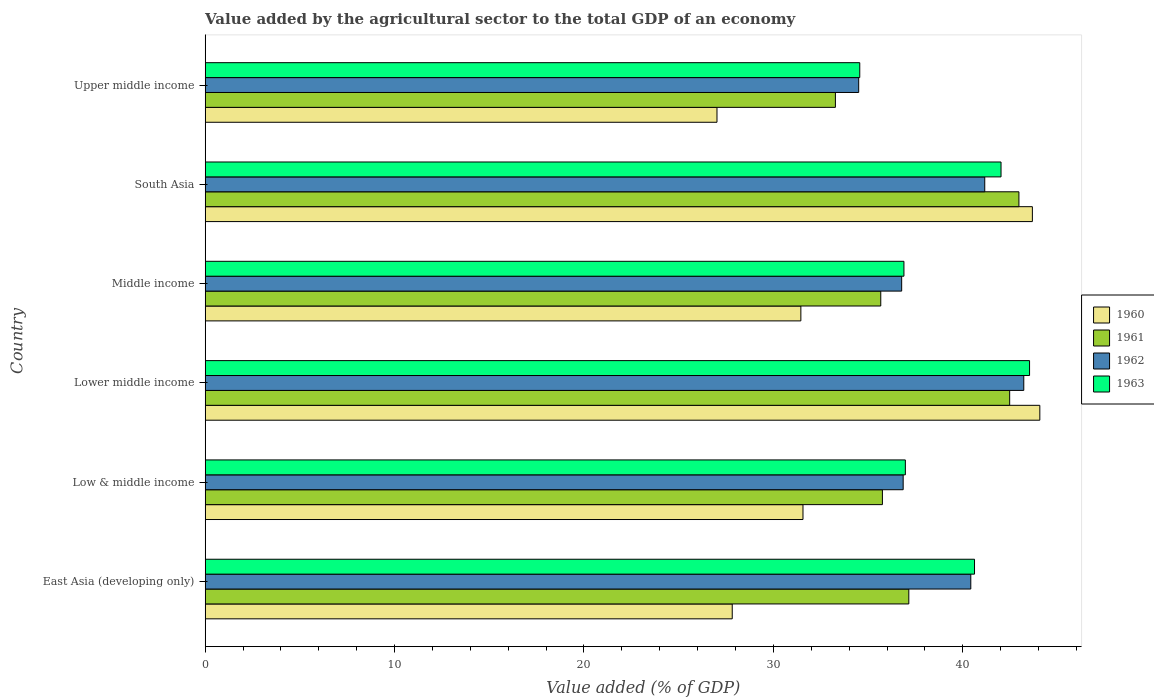Are the number of bars per tick equal to the number of legend labels?
Your answer should be very brief. Yes. How many bars are there on the 5th tick from the top?
Provide a succinct answer. 4. What is the label of the 4th group of bars from the top?
Keep it short and to the point. Lower middle income. In how many cases, is the number of bars for a given country not equal to the number of legend labels?
Make the answer very short. 0. What is the value added by the agricultural sector to the total GDP in 1963 in Upper middle income?
Offer a very short reply. 34.56. Across all countries, what is the maximum value added by the agricultural sector to the total GDP in 1962?
Your answer should be very brief. 43.22. Across all countries, what is the minimum value added by the agricultural sector to the total GDP in 1963?
Offer a very short reply. 34.56. In which country was the value added by the agricultural sector to the total GDP in 1960 maximum?
Your response must be concise. Lower middle income. In which country was the value added by the agricultural sector to the total GDP in 1961 minimum?
Your answer should be very brief. Upper middle income. What is the total value added by the agricultural sector to the total GDP in 1962 in the graph?
Make the answer very short. 232.94. What is the difference between the value added by the agricultural sector to the total GDP in 1963 in Low & middle income and that in South Asia?
Give a very brief answer. -5.05. What is the difference between the value added by the agricultural sector to the total GDP in 1961 in South Asia and the value added by the agricultural sector to the total GDP in 1963 in Upper middle income?
Provide a short and direct response. 8.4. What is the average value added by the agricultural sector to the total GDP in 1961 per country?
Give a very brief answer. 37.88. What is the difference between the value added by the agricultural sector to the total GDP in 1963 and value added by the agricultural sector to the total GDP in 1962 in Upper middle income?
Ensure brevity in your answer.  0.06. In how many countries, is the value added by the agricultural sector to the total GDP in 1962 greater than 18 %?
Give a very brief answer. 6. What is the ratio of the value added by the agricultural sector to the total GDP in 1960 in East Asia (developing only) to that in Middle income?
Provide a short and direct response. 0.88. Is the value added by the agricultural sector to the total GDP in 1961 in Low & middle income less than that in Lower middle income?
Give a very brief answer. Yes. What is the difference between the highest and the second highest value added by the agricultural sector to the total GDP in 1961?
Your response must be concise. 0.49. What is the difference between the highest and the lowest value added by the agricultural sector to the total GDP in 1961?
Your response must be concise. 9.69. In how many countries, is the value added by the agricultural sector to the total GDP in 1961 greater than the average value added by the agricultural sector to the total GDP in 1961 taken over all countries?
Your answer should be very brief. 2. Is the sum of the value added by the agricultural sector to the total GDP in 1961 in Lower middle income and Middle income greater than the maximum value added by the agricultural sector to the total GDP in 1960 across all countries?
Offer a very short reply. Yes. Is it the case that in every country, the sum of the value added by the agricultural sector to the total GDP in 1963 and value added by the agricultural sector to the total GDP in 1962 is greater than the sum of value added by the agricultural sector to the total GDP in 1960 and value added by the agricultural sector to the total GDP in 1961?
Provide a short and direct response. No. What does the 4th bar from the top in Lower middle income represents?
Your answer should be very brief. 1960. Are all the bars in the graph horizontal?
Your response must be concise. Yes. What is the difference between two consecutive major ticks on the X-axis?
Keep it short and to the point. 10. Are the values on the major ticks of X-axis written in scientific E-notation?
Provide a succinct answer. No. Does the graph contain any zero values?
Make the answer very short. No. How many legend labels are there?
Offer a terse response. 4. How are the legend labels stacked?
Give a very brief answer. Vertical. What is the title of the graph?
Your answer should be very brief. Value added by the agricultural sector to the total GDP of an economy. What is the label or title of the X-axis?
Provide a short and direct response. Value added (% of GDP). What is the label or title of the Y-axis?
Ensure brevity in your answer.  Country. What is the Value added (% of GDP) in 1960 in East Asia (developing only)?
Keep it short and to the point. 27.83. What is the Value added (% of GDP) in 1961 in East Asia (developing only)?
Provide a short and direct response. 37.15. What is the Value added (% of GDP) in 1962 in East Asia (developing only)?
Offer a very short reply. 40.42. What is the Value added (% of GDP) of 1963 in East Asia (developing only)?
Provide a succinct answer. 40.62. What is the Value added (% of GDP) of 1960 in Low & middle income?
Offer a very short reply. 31.56. What is the Value added (% of GDP) in 1961 in Low & middle income?
Offer a terse response. 35.76. What is the Value added (% of GDP) in 1962 in Low & middle income?
Your response must be concise. 36.85. What is the Value added (% of GDP) in 1963 in Low & middle income?
Provide a succinct answer. 36.97. What is the Value added (% of GDP) in 1960 in Lower middle income?
Offer a terse response. 44.07. What is the Value added (% of GDP) of 1961 in Lower middle income?
Give a very brief answer. 42.48. What is the Value added (% of GDP) of 1962 in Lower middle income?
Your answer should be compact. 43.22. What is the Value added (% of GDP) of 1963 in Lower middle income?
Make the answer very short. 43.53. What is the Value added (% of GDP) in 1960 in Middle income?
Provide a succinct answer. 31.45. What is the Value added (% of GDP) in 1961 in Middle income?
Give a very brief answer. 35.67. What is the Value added (% of GDP) of 1962 in Middle income?
Your response must be concise. 36.77. What is the Value added (% of GDP) in 1963 in Middle income?
Your answer should be compact. 36.89. What is the Value added (% of GDP) in 1960 in South Asia?
Offer a terse response. 43.68. What is the Value added (% of GDP) in 1961 in South Asia?
Your answer should be compact. 42.96. What is the Value added (% of GDP) of 1962 in South Asia?
Give a very brief answer. 41.16. What is the Value added (% of GDP) of 1963 in South Asia?
Make the answer very short. 42.02. What is the Value added (% of GDP) of 1960 in Upper middle income?
Your response must be concise. 27.02. What is the Value added (% of GDP) in 1961 in Upper middle income?
Your response must be concise. 33.27. What is the Value added (% of GDP) of 1962 in Upper middle income?
Ensure brevity in your answer.  34.5. What is the Value added (% of GDP) in 1963 in Upper middle income?
Offer a terse response. 34.56. Across all countries, what is the maximum Value added (% of GDP) of 1960?
Your answer should be very brief. 44.07. Across all countries, what is the maximum Value added (% of GDP) in 1961?
Your answer should be very brief. 42.96. Across all countries, what is the maximum Value added (% of GDP) in 1962?
Offer a terse response. 43.22. Across all countries, what is the maximum Value added (% of GDP) of 1963?
Give a very brief answer. 43.53. Across all countries, what is the minimum Value added (% of GDP) in 1960?
Your response must be concise. 27.02. Across all countries, what is the minimum Value added (% of GDP) in 1961?
Give a very brief answer. 33.27. Across all countries, what is the minimum Value added (% of GDP) in 1962?
Offer a very short reply. 34.5. Across all countries, what is the minimum Value added (% of GDP) in 1963?
Offer a very short reply. 34.56. What is the total Value added (% of GDP) of 1960 in the graph?
Provide a succinct answer. 205.61. What is the total Value added (% of GDP) in 1961 in the graph?
Make the answer very short. 227.29. What is the total Value added (% of GDP) in 1962 in the graph?
Offer a terse response. 232.94. What is the total Value added (% of GDP) of 1963 in the graph?
Offer a terse response. 234.59. What is the difference between the Value added (% of GDP) in 1960 in East Asia (developing only) and that in Low & middle income?
Ensure brevity in your answer.  -3.74. What is the difference between the Value added (% of GDP) in 1961 in East Asia (developing only) and that in Low & middle income?
Your answer should be very brief. 1.39. What is the difference between the Value added (% of GDP) of 1962 in East Asia (developing only) and that in Low & middle income?
Your response must be concise. 3.57. What is the difference between the Value added (% of GDP) of 1963 in East Asia (developing only) and that in Low & middle income?
Your answer should be compact. 3.65. What is the difference between the Value added (% of GDP) in 1960 in East Asia (developing only) and that in Lower middle income?
Your answer should be very brief. -16.24. What is the difference between the Value added (% of GDP) of 1961 in East Asia (developing only) and that in Lower middle income?
Provide a short and direct response. -5.33. What is the difference between the Value added (% of GDP) of 1962 in East Asia (developing only) and that in Lower middle income?
Provide a short and direct response. -2.8. What is the difference between the Value added (% of GDP) in 1963 in East Asia (developing only) and that in Lower middle income?
Your answer should be very brief. -2.91. What is the difference between the Value added (% of GDP) of 1960 in East Asia (developing only) and that in Middle income?
Your answer should be very brief. -3.62. What is the difference between the Value added (% of GDP) of 1961 in East Asia (developing only) and that in Middle income?
Your answer should be very brief. 1.48. What is the difference between the Value added (% of GDP) of 1962 in East Asia (developing only) and that in Middle income?
Make the answer very short. 3.65. What is the difference between the Value added (% of GDP) in 1963 in East Asia (developing only) and that in Middle income?
Provide a short and direct response. 3.73. What is the difference between the Value added (% of GDP) of 1960 in East Asia (developing only) and that in South Asia?
Keep it short and to the point. -15.85. What is the difference between the Value added (% of GDP) of 1961 in East Asia (developing only) and that in South Asia?
Keep it short and to the point. -5.81. What is the difference between the Value added (% of GDP) in 1962 in East Asia (developing only) and that in South Asia?
Give a very brief answer. -0.74. What is the difference between the Value added (% of GDP) of 1963 in East Asia (developing only) and that in South Asia?
Your answer should be compact. -1.4. What is the difference between the Value added (% of GDP) in 1960 in East Asia (developing only) and that in Upper middle income?
Make the answer very short. 0.81. What is the difference between the Value added (% of GDP) of 1961 in East Asia (developing only) and that in Upper middle income?
Provide a succinct answer. 3.88. What is the difference between the Value added (% of GDP) in 1962 in East Asia (developing only) and that in Upper middle income?
Your answer should be compact. 5.92. What is the difference between the Value added (% of GDP) of 1963 in East Asia (developing only) and that in Upper middle income?
Provide a short and direct response. 6.06. What is the difference between the Value added (% of GDP) of 1960 in Low & middle income and that in Lower middle income?
Your response must be concise. -12.51. What is the difference between the Value added (% of GDP) in 1961 in Low & middle income and that in Lower middle income?
Make the answer very short. -6.72. What is the difference between the Value added (% of GDP) of 1962 in Low & middle income and that in Lower middle income?
Provide a short and direct response. -6.37. What is the difference between the Value added (% of GDP) of 1963 in Low & middle income and that in Lower middle income?
Provide a succinct answer. -6.56. What is the difference between the Value added (% of GDP) of 1960 in Low & middle income and that in Middle income?
Offer a very short reply. 0.11. What is the difference between the Value added (% of GDP) of 1961 in Low & middle income and that in Middle income?
Your response must be concise. 0.09. What is the difference between the Value added (% of GDP) of 1962 in Low & middle income and that in Middle income?
Ensure brevity in your answer.  0.08. What is the difference between the Value added (% of GDP) in 1963 in Low & middle income and that in Middle income?
Keep it short and to the point. 0.07. What is the difference between the Value added (% of GDP) in 1960 in Low & middle income and that in South Asia?
Provide a succinct answer. -12.11. What is the difference between the Value added (% of GDP) in 1961 in Low & middle income and that in South Asia?
Provide a succinct answer. -7.21. What is the difference between the Value added (% of GDP) in 1962 in Low & middle income and that in South Asia?
Offer a terse response. -4.31. What is the difference between the Value added (% of GDP) in 1963 in Low & middle income and that in South Asia?
Your response must be concise. -5.05. What is the difference between the Value added (% of GDP) of 1960 in Low & middle income and that in Upper middle income?
Provide a short and direct response. 4.54. What is the difference between the Value added (% of GDP) in 1961 in Low & middle income and that in Upper middle income?
Make the answer very short. 2.48. What is the difference between the Value added (% of GDP) of 1962 in Low & middle income and that in Upper middle income?
Provide a short and direct response. 2.35. What is the difference between the Value added (% of GDP) of 1963 in Low & middle income and that in Upper middle income?
Ensure brevity in your answer.  2.41. What is the difference between the Value added (% of GDP) in 1960 in Lower middle income and that in Middle income?
Ensure brevity in your answer.  12.62. What is the difference between the Value added (% of GDP) in 1961 in Lower middle income and that in Middle income?
Make the answer very short. 6.81. What is the difference between the Value added (% of GDP) of 1962 in Lower middle income and that in Middle income?
Your response must be concise. 6.45. What is the difference between the Value added (% of GDP) in 1963 in Lower middle income and that in Middle income?
Provide a short and direct response. 6.63. What is the difference between the Value added (% of GDP) of 1960 in Lower middle income and that in South Asia?
Offer a very short reply. 0.39. What is the difference between the Value added (% of GDP) in 1961 in Lower middle income and that in South Asia?
Offer a terse response. -0.49. What is the difference between the Value added (% of GDP) in 1962 in Lower middle income and that in South Asia?
Your response must be concise. 2.06. What is the difference between the Value added (% of GDP) in 1963 in Lower middle income and that in South Asia?
Offer a terse response. 1.51. What is the difference between the Value added (% of GDP) of 1960 in Lower middle income and that in Upper middle income?
Offer a terse response. 17.05. What is the difference between the Value added (% of GDP) of 1961 in Lower middle income and that in Upper middle income?
Your response must be concise. 9.2. What is the difference between the Value added (% of GDP) of 1962 in Lower middle income and that in Upper middle income?
Offer a very short reply. 8.72. What is the difference between the Value added (% of GDP) in 1963 in Lower middle income and that in Upper middle income?
Provide a short and direct response. 8.97. What is the difference between the Value added (% of GDP) of 1960 in Middle income and that in South Asia?
Your answer should be very brief. -12.22. What is the difference between the Value added (% of GDP) of 1961 in Middle income and that in South Asia?
Provide a short and direct response. -7.29. What is the difference between the Value added (% of GDP) of 1962 in Middle income and that in South Asia?
Keep it short and to the point. -4.39. What is the difference between the Value added (% of GDP) of 1963 in Middle income and that in South Asia?
Keep it short and to the point. -5.13. What is the difference between the Value added (% of GDP) of 1960 in Middle income and that in Upper middle income?
Your answer should be compact. 4.43. What is the difference between the Value added (% of GDP) of 1961 in Middle income and that in Upper middle income?
Your answer should be compact. 2.4. What is the difference between the Value added (% of GDP) of 1962 in Middle income and that in Upper middle income?
Give a very brief answer. 2.27. What is the difference between the Value added (% of GDP) in 1963 in Middle income and that in Upper middle income?
Your answer should be compact. 2.33. What is the difference between the Value added (% of GDP) of 1960 in South Asia and that in Upper middle income?
Offer a terse response. 16.65. What is the difference between the Value added (% of GDP) of 1961 in South Asia and that in Upper middle income?
Give a very brief answer. 9.69. What is the difference between the Value added (% of GDP) of 1962 in South Asia and that in Upper middle income?
Ensure brevity in your answer.  6.66. What is the difference between the Value added (% of GDP) of 1963 in South Asia and that in Upper middle income?
Provide a short and direct response. 7.46. What is the difference between the Value added (% of GDP) in 1960 in East Asia (developing only) and the Value added (% of GDP) in 1961 in Low & middle income?
Your answer should be compact. -7.93. What is the difference between the Value added (% of GDP) of 1960 in East Asia (developing only) and the Value added (% of GDP) of 1962 in Low & middle income?
Give a very brief answer. -9.02. What is the difference between the Value added (% of GDP) in 1960 in East Asia (developing only) and the Value added (% of GDP) in 1963 in Low & middle income?
Give a very brief answer. -9.14. What is the difference between the Value added (% of GDP) of 1961 in East Asia (developing only) and the Value added (% of GDP) of 1962 in Low & middle income?
Offer a terse response. 0.3. What is the difference between the Value added (% of GDP) in 1961 in East Asia (developing only) and the Value added (% of GDP) in 1963 in Low & middle income?
Keep it short and to the point. 0.18. What is the difference between the Value added (% of GDP) of 1962 in East Asia (developing only) and the Value added (% of GDP) of 1963 in Low & middle income?
Ensure brevity in your answer.  3.46. What is the difference between the Value added (% of GDP) of 1960 in East Asia (developing only) and the Value added (% of GDP) of 1961 in Lower middle income?
Your answer should be compact. -14.65. What is the difference between the Value added (% of GDP) of 1960 in East Asia (developing only) and the Value added (% of GDP) of 1962 in Lower middle income?
Ensure brevity in your answer.  -15.39. What is the difference between the Value added (% of GDP) in 1960 in East Asia (developing only) and the Value added (% of GDP) in 1963 in Lower middle income?
Your answer should be compact. -15.7. What is the difference between the Value added (% of GDP) in 1961 in East Asia (developing only) and the Value added (% of GDP) in 1962 in Lower middle income?
Ensure brevity in your answer.  -6.07. What is the difference between the Value added (% of GDP) of 1961 in East Asia (developing only) and the Value added (% of GDP) of 1963 in Lower middle income?
Ensure brevity in your answer.  -6.38. What is the difference between the Value added (% of GDP) in 1962 in East Asia (developing only) and the Value added (% of GDP) in 1963 in Lower middle income?
Provide a short and direct response. -3.1. What is the difference between the Value added (% of GDP) in 1960 in East Asia (developing only) and the Value added (% of GDP) in 1961 in Middle income?
Your answer should be compact. -7.84. What is the difference between the Value added (% of GDP) of 1960 in East Asia (developing only) and the Value added (% of GDP) of 1962 in Middle income?
Offer a very short reply. -8.95. What is the difference between the Value added (% of GDP) in 1960 in East Asia (developing only) and the Value added (% of GDP) in 1963 in Middle income?
Ensure brevity in your answer.  -9.07. What is the difference between the Value added (% of GDP) of 1961 in East Asia (developing only) and the Value added (% of GDP) of 1962 in Middle income?
Provide a short and direct response. 0.38. What is the difference between the Value added (% of GDP) in 1961 in East Asia (developing only) and the Value added (% of GDP) in 1963 in Middle income?
Offer a very short reply. 0.26. What is the difference between the Value added (% of GDP) in 1962 in East Asia (developing only) and the Value added (% of GDP) in 1963 in Middle income?
Ensure brevity in your answer.  3.53. What is the difference between the Value added (% of GDP) in 1960 in East Asia (developing only) and the Value added (% of GDP) in 1961 in South Asia?
Offer a very short reply. -15.14. What is the difference between the Value added (% of GDP) of 1960 in East Asia (developing only) and the Value added (% of GDP) of 1962 in South Asia?
Ensure brevity in your answer.  -13.33. What is the difference between the Value added (% of GDP) of 1960 in East Asia (developing only) and the Value added (% of GDP) of 1963 in South Asia?
Offer a terse response. -14.19. What is the difference between the Value added (% of GDP) of 1961 in East Asia (developing only) and the Value added (% of GDP) of 1962 in South Asia?
Provide a succinct answer. -4.01. What is the difference between the Value added (% of GDP) of 1961 in East Asia (developing only) and the Value added (% of GDP) of 1963 in South Asia?
Your response must be concise. -4.87. What is the difference between the Value added (% of GDP) of 1962 in East Asia (developing only) and the Value added (% of GDP) of 1963 in South Asia?
Offer a terse response. -1.6. What is the difference between the Value added (% of GDP) in 1960 in East Asia (developing only) and the Value added (% of GDP) in 1961 in Upper middle income?
Your response must be concise. -5.45. What is the difference between the Value added (% of GDP) of 1960 in East Asia (developing only) and the Value added (% of GDP) of 1962 in Upper middle income?
Give a very brief answer. -6.68. What is the difference between the Value added (% of GDP) in 1960 in East Asia (developing only) and the Value added (% of GDP) in 1963 in Upper middle income?
Provide a short and direct response. -6.73. What is the difference between the Value added (% of GDP) in 1961 in East Asia (developing only) and the Value added (% of GDP) in 1962 in Upper middle income?
Offer a terse response. 2.65. What is the difference between the Value added (% of GDP) in 1961 in East Asia (developing only) and the Value added (% of GDP) in 1963 in Upper middle income?
Your answer should be compact. 2.59. What is the difference between the Value added (% of GDP) in 1962 in East Asia (developing only) and the Value added (% of GDP) in 1963 in Upper middle income?
Keep it short and to the point. 5.86. What is the difference between the Value added (% of GDP) in 1960 in Low & middle income and the Value added (% of GDP) in 1961 in Lower middle income?
Your answer should be very brief. -10.91. What is the difference between the Value added (% of GDP) in 1960 in Low & middle income and the Value added (% of GDP) in 1962 in Lower middle income?
Provide a succinct answer. -11.66. What is the difference between the Value added (% of GDP) of 1960 in Low & middle income and the Value added (% of GDP) of 1963 in Lower middle income?
Keep it short and to the point. -11.96. What is the difference between the Value added (% of GDP) of 1961 in Low & middle income and the Value added (% of GDP) of 1962 in Lower middle income?
Make the answer very short. -7.47. What is the difference between the Value added (% of GDP) in 1961 in Low & middle income and the Value added (% of GDP) in 1963 in Lower middle income?
Offer a terse response. -7.77. What is the difference between the Value added (% of GDP) in 1962 in Low & middle income and the Value added (% of GDP) in 1963 in Lower middle income?
Make the answer very short. -6.67. What is the difference between the Value added (% of GDP) in 1960 in Low & middle income and the Value added (% of GDP) in 1961 in Middle income?
Offer a very short reply. -4.11. What is the difference between the Value added (% of GDP) in 1960 in Low & middle income and the Value added (% of GDP) in 1962 in Middle income?
Your response must be concise. -5.21. What is the difference between the Value added (% of GDP) in 1960 in Low & middle income and the Value added (% of GDP) in 1963 in Middle income?
Offer a very short reply. -5.33. What is the difference between the Value added (% of GDP) of 1961 in Low & middle income and the Value added (% of GDP) of 1962 in Middle income?
Provide a succinct answer. -1.02. What is the difference between the Value added (% of GDP) of 1961 in Low & middle income and the Value added (% of GDP) of 1963 in Middle income?
Ensure brevity in your answer.  -1.14. What is the difference between the Value added (% of GDP) in 1962 in Low & middle income and the Value added (% of GDP) in 1963 in Middle income?
Provide a short and direct response. -0.04. What is the difference between the Value added (% of GDP) in 1960 in Low & middle income and the Value added (% of GDP) in 1961 in South Asia?
Ensure brevity in your answer.  -11.4. What is the difference between the Value added (% of GDP) in 1960 in Low & middle income and the Value added (% of GDP) in 1962 in South Asia?
Make the answer very short. -9.6. What is the difference between the Value added (% of GDP) of 1960 in Low & middle income and the Value added (% of GDP) of 1963 in South Asia?
Your answer should be very brief. -10.46. What is the difference between the Value added (% of GDP) in 1961 in Low & middle income and the Value added (% of GDP) in 1962 in South Asia?
Keep it short and to the point. -5.4. What is the difference between the Value added (% of GDP) in 1961 in Low & middle income and the Value added (% of GDP) in 1963 in South Asia?
Offer a very short reply. -6.26. What is the difference between the Value added (% of GDP) in 1962 in Low & middle income and the Value added (% of GDP) in 1963 in South Asia?
Provide a succinct answer. -5.17. What is the difference between the Value added (% of GDP) of 1960 in Low & middle income and the Value added (% of GDP) of 1961 in Upper middle income?
Keep it short and to the point. -1.71. What is the difference between the Value added (% of GDP) in 1960 in Low & middle income and the Value added (% of GDP) in 1962 in Upper middle income?
Your answer should be compact. -2.94. What is the difference between the Value added (% of GDP) in 1960 in Low & middle income and the Value added (% of GDP) in 1963 in Upper middle income?
Provide a succinct answer. -3. What is the difference between the Value added (% of GDP) of 1961 in Low & middle income and the Value added (% of GDP) of 1962 in Upper middle income?
Give a very brief answer. 1.25. What is the difference between the Value added (% of GDP) in 1961 in Low & middle income and the Value added (% of GDP) in 1963 in Upper middle income?
Provide a succinct answer. 1.2. What is the difference between the Value added (% of GDP) in 1962 in Low & middle income and the Value added (% of GDP) in 1963 in Upper middle income?
Give a very brief answer. 2.29. What is the difference between the Value added (% of GDP) of 1960 in Lower middle income and the Value added (% of GDP) of 1961 in Middle income?
Provide a succinct answer. 8.4. What is the difference between the Value added (% of GDP) in 1960 in Lower middle income and the Value added (% of GDP) in 1962 in Middle income?
Your answer should be very brief. 7.29. What is the difference between the Value added (% of GDP) of 1960 in Lower middle income and the Value added (% of GDP) of 1963 in Middle income?
Provide a succinct answer. 7.17. What is the difference between the Value added (% of GDP) of 1961 in Lower middle income and the Value added (% of GDP) of 1962 in Middle income?
Your response must be concise. 5.7. What is the difference between the Value added (% of GDP) of 1961 in Lower middle income and the Value added (% of GDP) of 1963 in Middle income?
Your answer should be compact. 5.58. What is the difference between the Value added (% of GDP) in 1962 in Lower middle income and the Value added (% of GDP) in 1963 in Middle income?
Your answer should be very brief. 6.33. What is the difference between the Value added (% of GDP) of 1960 in Lower middle income and the Value added (% of GDP) of 1961 in South Asia?
Offer a terse response. 1.1. What is the difference between the Value added (% of GDP) in 1960 in Lower middle income and the Value added (% of GDP) in 1962 in South Asia?
Make the answer very short. 2.91. What is the difference between the Value added (% of GDP) of 1960 in Lower middle income and the Value added (% of GDP) of 1963 in South Asia?
Keep it short and to the point. 2.05. What is the difference between the Value added (% of GDP) in 1961 in Lower middle income and the Value added (% of GDP) in 1962 in South Asia?
Give a very brief answer. 1.32. What is the difference between the Value added (% of GDP) of 1961 in Lower middle income and the Value added (% of GDP) of 1963 in South Asia?
Offer a terse response. 0.46. What is the difference between the Value added (% of GDP) of 1962 in Lower middle income and the Value added (% of GDP) of 1963 in South Asia?
Give a very brief answer. 1.2. What is the difference between the Value added (% of GDP) in 1960 in Lower middle income and the Value added (% of GDP) in 1961 in Upper middle income?
Your answer should be compact. 10.79. What is the difference between the Value added (% of GDP) of 1960 in Lower middle income and the Value added (% of GDP) of 1962 in Upper middle income?
Your answer should be compact. 9.56. What is the difference between the Value added (% of GDP) in 1960 in Lower middle income and the Value added (% of GDP) in 1963 in Upper middle income?
Give a very brief answer. 9.51. What is the difference between the Value added (% of GDP) of 1961 in Lower middle income and the Value added (% of GDP) of 1962 in Upper middle income?
Your answer should be very brief. 7.97. What is the difference between the Value added (% of GDP) of 1961 in Lower middle income and the Value added (% of GDP) of 1963 in Upper middle income?
Offer a very short reply. 7.92. What is the difference between the Value added (% of GDP) of 1962 in Lower middle income and the Value added (% of GDP) of 1963 in Upper middle income?
Your answer should be compact. 8.66. What is the difference between the Value added (% of GDP) of 1960 in Middle income and the Value added (% of GDP) of 1961 in South Asia?
Provide a succinct answer. -11.51. What is the difference between the Value added (% of GDP) of 1960 in Middle income and the Value added (% of GDP) of 1962 in South Asia?
Make the answer very short. -9.71. What is the difference between the Value added (% of GDP) of 1960 in Middle income and the Value added (% of GDP) of 1963 in South Asia?
Offer a terse response. -10.57. What is the difference between the Value added (% of GDP) of 1961 in Middle income and the Value added (% of GDP) of 1962 in South Asia?
Your response must be concise. -5.49. What is the difference between the Value added (% of GDP) of 1961 in Middle income and the Value added (% of GDP) of 1963 in South Asia?
Ensure brevity in your answer.  -6.35. What is the difference between the Value added (% of GDP) in 1962 in Middle income and the Value added (% of GDP) in 1963 in South Asia?
Offer a very short reply. -5.25. What is the difference between the Value added (% of GDP) in 1960 in Middle income and the Value added (% of GDP) in 1961 in Upper middle income?
Keep it short and to the point. -1.82. What is the difference between the Value added (% of GDP) in 1960 in Middle income and the Value added (% of GDP) in 1962 in Upper middle income?
Provide a short and direct response. -3.05. What is the difference between the Value added (% of GDP) of 1960 in Middle income and the Value added (% of GDP) of 1963 in Upper middle income?
Provide a succinct answer. -3.11. What is the difference between the Value added (% of GDP) in 1961 in Middle income and the Value added (% of GDP) in 1962 in Upper middle income?
Offer a very short reply. 1.17. What is the difference between the Value added (% of GDP) in 1961 in Middle income and the Value added (% of GDP) in 1963 in Upper middle income?
Offer a terse response. 1.11. What is the difference between the Value added (% of GDP) in 1962 in Middle income and the Value added (% of GDP) in 1963 in Upper middle income?
Keep it short and to the point. 2.21. What is the difference between the Value added (% of GDP) in 1960 in South Asia and the Value added (% of GDP) in 1961 in Upper middle income?
Make the answer very short. 10.4. What is the difference between the Value added (% of GDP) of 1960 in South Asia and the Value added (% of GDP) of 1962 in Upper middle income?
Your answer should be compact. 9.17. What is the difference between the Value added (% of GDP) of 1960 in South Asia and the Value added (% of GDP) of 1963 in Upper middle income?
Provide a short and direct response. 9.11. What is the difference between the Value added (% of GDP) in 1961 in South Asia and the Value added (% of GDP) in 1962 in Upper middle income?
Offer a terse response. 8.46. What is the difference between the Value added (% of GDP) of 1961 in South Asia and the Value added (% of GDP) of 1963 in Upper middle income?
Ensure brevity in your answer.  8.4. What is the difference between the Value added (% of GDP) of 1962 in South Asia and the Value added (% of GDP) of 1963 in Upper middle income?
Make the answer very short. 6.6. What is the average Value added (% of GDP) in 1960 per country?
Your answer should be very brief. 34.27. What is the average Value added (% of GDP) of 1961 per country?
Offer a terse response. 37.88. What is the average Value added (% of GDP) in 1962 per country?
Your answer should be very brief. 38.82. What is the average Value added (% of GDP) of 1963 per country?
Provide a short and direct response. 39.1. What is the difference between the Value added (% of GDP) of 1960 and Value added (% of GDP) of 1961 in East Asia (developing only)?
Offer a terse response. -9.32. What is the difference between the Value added (% of GDP) in 1960 and Value added (% of GDP) in 1962 in East Asia (developing only)?
Your answer should be very brief. -12.6. What is the difference between the Value added (% of GDP) of 1960 and Value added (% of GDP) of 1963 in East Asia (developing only)?
Provide a succinct answer. -12.79. What is the difference between the Value added (% of GDP) of 1961 and Value added (% of GDP) of 1962 in East Asia (developing only)?
Ensure brevity in your answer.  -3.27. What is the difference between the Value added (% of GDP) of 1961 and Value added (% of GDP) of 1963 in East Asia (developing only)?
Offer a terse response. -3.47. What is the difference between the Value added (% of GDP) of 1962 and Value added (% of GDP) of 1963 in East Asia (developing only)?
Your answer should be very brief. -0.2. What is the difference between the Value added (% of GDP) in 1960 and Value added (% of GDP) in 1961 in Low & middle income?
Ensure brevity in your answer.  -4.19. What is the difference between the Value added (% of GDP) of 1960 and Value added (% of GDP) of 1962 in Low & middle income?
Offer a terse response. -5.29. What is the difference between the Value added (% of GDP) in 1960 and Value added (% of GDP) in 1963 in Low & middle income?
Ensure brevity in your answer.  -5.41. What is the difference between the Value added (% of GDP) in 1961 and Value added (% of GDP) in 1962 in Low & middle income?
Offer a terse response. -1.1. What is the difference between the Value added (% of GDP) in 1961 and Value added (% of GDP) in 1963 in Low & middle income?
Ensure brevity in your answer.  -1.21. What is the difference between the Value added (% of GDP) of 1962 and Value added (% of GDP) of 1963 in Low & middle income?
Provide a succinct answer. -0.12. What is the difference between the Value added (% of GDP) in 1960 and Value added (% of GDP) in 1961 in Lower middle income?
Provide a succinct answer. 1.59. What is the difference between the Value added (% of GDP) in 1960 and Value added (% of GDP) in 1962 in Lower middle income?
Your response must be concise. 0.85. What is the difference between the Value added (% of GDP) in 1960 and Value added (% of GDP) in 1963 in Lower middle income?
Give a very brief answer. 0.54. What is the difference between the Value added (% of GDP) in 1961 and Value added (% of GDP) in 1962 in Lower middle income?
Give a very brief answer. -0.75. What is the difference between the Value added (% of GDP) in 1961 and Value added (% of GDP) in 1963 in Lower middle income?
Provide a short and direct response. -1.05. What is the difference between the Value added (% of GDP) of 1962 and Value added (% of GDP) of 1963 in Lower middle income?
Keep it short and to the point. -0.3. What is the difference between the Value added (% of GDP) of 1960 and Value added (% of GDP) of 1961 in Middle income?
Make the answer very short. -4.22. What is the difference between the Value added (% of GDP) in 1960 and Value added (% of GDP) in 1962 in Middle income?
Keep it short and to the point. -5.32. What is the difference between the Value added (% of GDP) of 1960 and Value added (% of GDP) of 1963 in Middle income?
Offer a very short reply. -5.44. What is the difference between the Value added (% of GDP) of 1961 and Value added (% of GDP) of 1962 in Middle income?
Ensure brevity in your answer.  -1.1. What is the difference between the Value added (% of GDP) in 1961 and Value added (% of GDP) in 1963 in Middle income?
Keep it short and to the point. -1.22. What is the difference between the Value added (% of GDP) of 1962 and Value added (% of GDP) of 1963 in Middle income?
Offer a terse response. -0.12. What is the difference between the Value added (% of GDP) of 1960 and Value added (% of GDP) of 1961 in South Asia?
Keep it short and to the point. 0.71. What is the difference between the Value added (% of GDP) in 1960 and Value added (% of GDP) in 1962 in South Asia?
Give a very brief answer. 2.52. What is the difference between the Value added (% of GDP) in 1960 and Value added (% of GDP) in 1963 in South Asia?
Offer a terse response. 1.66. What is the difference between the Value added (% of GDP) of 1961 and Value added (% of GDP) of 1962 in South Asia?
Your response must be concise. 1.8. What is the difference between the Value added (% of GDP) in 1961 and Value added (% of GDP) in 1963 in South Asia?
Provide a short and direct response. 0.95. What is the difference between the Value added (% of GDP) in 1962 and Value added (% of GDP) in 1963 in South Asia?
Your answer should be very brief. -0.86. What is the difference between the Value added (% of GDP) of 1960 and Value added (% of GDP) of 1961 in Upper middle income?
Your answer should be compact. -6.25. What is the difference between the Value added (% of GDP) in 1960 and Value added (% of GDP) in 1962 in Upper middle income?
Give a very brief answer. -7.48. What is the difference between the Value added (% of GDP) in 1960 and Value added (% of GDP) in 1963 in Upper middle income?
Offer a terse response. -7.54. What is the difference between the Value added (% of GDP) in 1961 and Value added (% of GDP) in 1962 in Upper middle income?
Ensure brevity in your answer.  -1.23. What is the difference between the Value added (% of GDP) of 1961 and Value added (% of GDP) of 1963 in Upper middle income?
Offer a terse response. -1.29. What is the difference between the Value added (% of GDP) of 1962 and Value added (% of GDP) of 1963 in Upper middle income?
Offer a terse response. -0.06. What is the ratio of the Value added (% of GDP) of 1960 in East Asia (developing only) to that in Low & middle income?
Your answer should be compact. 0.88. What is the ratio of the Value added (% of GDP) in 1961 in East Asia (developing only) to that in Low & middle income?
Your answer should be very brief. 1.04. What is the ratio of the Value added (% of GDP) of 1962 in East Asia (developing only) to that in Low & middle income?
Provide a succinct answer. 1.1. What is the ratio of the Value added (% of GDP) in 1963 in East Asia (developing only) to that in Low & middle income?
Offer a very short reply. 1.1. What is the ratio of the Value added (% of GDP) of 1960 in East Asia (developing only) to that in Lower middle income?
Your answer should be very brief. 0.63. What is the ratio of the Value added (% of GDP) in 1961 in East Asia (developing only) to that in Lower middle income?
Your response must be concise. 0.87. What is the ratio of the Value added (% of GDP) in 1962 in East Asia (developing only) to that in Lower middle income?
Your answer should be very brief. 0.94. What is the ratio of the Value added (% of GDP) in 1963 in East Asia (developing only) to that in Lower middle income?
Make the answer very short. 0.93. What is the ratio of the Value added (% of GDP) in 1960 in East Asia (developing only) to that in Middle income?
Give a very brief answer. 0.88. What is the ratio of the Value added (% of GDP) of 1961 in East Asia (developing only) to that in Middle income?
Offer a very short reply. 1.04. What is the ratio of the Value added (% of GDP) in 1962 in East Asia (developing only) to that in Middle income?
Make the answer very short. 1.1. What is the ratio of the Value added (% of GDP) in 1963 in East Asia (developing only) to that in Middle income?
Provide a short and direct response. 1.1. What is the ratio of the Value added (% of GDP) of 1960 in East Asia (developing only) to that in South Asia?
Make the answer very short. 0.64. What is the ratio of the Value added (% of GDP) in 1961 in East Asia (developing only) to that in South Asia?
Make the answer very short. 0.86. What is the ratio of the Value added (% of GDP) of 1962 in East Asia (developing only) to that in South Asia?
Your response must be concise. 0.98. What is the ratio of the Value added (% of GDP) in 1963 in East Asia (developing only) to that in South Asia?
Your answer should be compact. 0.97. What is the ratio of the Value added (% of GDP) of 1960 in East Asia (developing only) to that in Upper middle income?
Your response must be concise. 1.03. What is the ratio of the Value added (% of GDP) in 1961 in East Asia (developing only) to that in Upper middle income?
Ensure brevity in your answer.  1.12. What is the ratio of the Value added (% of GDP) of 1962 in East Asia (developing only) to that in Upper middle income?
Ensure brevity in your answer.  1.17. What is the ratio of the Value added (% of GDP) of 1963 in East Asia (developing only) to that in Upper middle income?
Your answer should be compact. 1.18. What is the ratio of the Value added (% of GDP) of 1960 in Low & middle income to that in Lower middle income?
Ensure brevity in your answer.  0.72. What is the ratio of the Value added (% of GDP) in 1961 in Low & middle income to that in Lower middle income?
Provide a short and direct response. 0.84. What is the ratio of the Value added (% of GDP) of 1962 in Low & middle income to that in Lower middle income?
Your answer should be compact. 0.85. What is the ratio of the Value added (% of GDP) in 1963 in Low & middle income to that in Lower middle income?
Give a very brief answer. 0.85. What is the ratio of the Value added (% of GDP) in 1960 in Low & middle income to that in Middle income?
Offer a very short reply. 1. What is the ratio of the Value added (% of GDP) of 1961 in Low & middle income to that in Middle income?
Give a very brief answer. 1. What is the ratio of the Value added (% of GDP) in 1960 in Low & middle income to that in South Asia?
Offer a terse response. 0.72. What is the ratio of the Value added (% of GDP) in 1961 in Low & middle income to that in South Asia?
Offer a terse response. 0.83. What is the ratio of the Value added (% of GDP) of 1962 in Low & middle income to that in South Asia?
Keep it short and to the point. 0.9. What is the ratio of the Value added (% of GDP) of 1963 in Low & middle income to that in South Asia?
Keep it short and to the point. 0.88. What is the ratio of the Value added (% of GDP) in 1960 in Low & middle income to that in Upper middle income?
Ensure brevity in your answer.  1.17. What is the ratio of the Value added (% of GDP) of 1961 in Low & middle income to that in Upper middle income?
Your answer should be compact. 1.07. What is the ratio of the Value added (% of GDP) in 1962 in Low & middle income to that in Upper middle income?
Offer a terse response. 1.07. What is the ratio of the Value added (% of GDP) of 1963 in Low & middle income to that in Upper middle income?
Ensure brevity in your answer.  1.07. What is the ratio of the Value added (% of GDP) of 1960 in Lower middle income to that in Middle income?
Your answer should be very brief. 1.4. What is the ratio of the Value added (% of GDP) of 1961 in Lower middle income to that in Middle income?
Keep it short and to the point. 1.19. What is the ratio of the Value added (% of GDP) of 1962 in Lower middle income to that in Middle income?
Your answer should be very brief. 1.18. What is the ratio of the Value added (% of GDP) in 1963 in Lower middle income to that in Middle income?
Your response must be concise. 1.18. What is the ratio of the Value added (% of GDP) of 1960 in Lower middle income to that in South Asia?
Your response must be concise. 1.01. What is the ratio of the Value added (% of GDP) of 1961 in Lower middle income to that in South Asia?
Provide a succinct answer. 0.99. What is the ratio of the Value added (% of GDP) in 1962 in Lower middle income to that in South Asia?
Keep it short and to the point. 1.05. What is the ratio of the Value added (% of GDP) in 1963 in Lower middle income to that in South Asia?
Provide a short and direct response. 1.04. What is the ratio of the Value added (% of GDP) in 1960 in Lower middle income to that in Upper middle income?
Your response must be concise. 1.63. What is the ratio of the Value added (% of GDP) of 1961 in Lower middle income to that in Upper middle income?
Your response must be concise. 1.28. What is the ratio of the Value added (% of GDP) in 1962 in Lower middle income to that in Upper middle income?
Your answer should be very brief. 1.25. What is the ratio of the Value added (% of GDP) in 1963 in Lower middle income to that in Upper middle income?
Your response must be concise. 1.26. What is the ratio of the Value added (% of GDP) of 1960 in Middle income to that in South Asia?
Keep it short and to the point. 0.72. What is the ratio of the Value added (% of GDP) in 1961 in Middle income to that in South Asia?
Keep it short and to the point. 0.83. What is the ratio of the Value added (% of GDP) in 1962 in Middle income to that in South Asia?
Offer a terse response. 0.89. What is the ratio of the Value added (% of GDP) in 1963 in Middle income to that in South Asia?
Provide a short and direct response. 0.88. What is the ratio of the Value added (% of GDP) of 1960 in Middle income to that in Upper middle income?
Your response must be concise. 1.16. What is the ratio of the Value added (% of GDP) in 1961 in Middle income to that in Upper middle income?
Ensure brevity in your answer.  1.07. What is the ratio of the Value added (% of GDP) of 1962 in Middle income to that in Upper middle income?
Provide a short and direct response. 1.07. What is the ratio of the Value added (% of GDP) in 1963 in Middle income to that in Upper middle income?
Provide a succinct answer. 1.07. What is the ratio of the Value added (% of GDP) of 1960 in South Asia to that in Upper middle income?
Keep it short and to the point. 1.62. What is the ratio of the Value added (% of GDP) of 1961 in South Asia to that in Upper middle income?
Give a very brief answer. 1.29. What is the ratio of the Value added (% of GDP) of 1962 in South Asia to that in Upper middle income?
Your answer should be compact. 1.19. What is the ratio of the Value added (% of GDP) of 1963 in South Asia to that in Upper middle income?
Provide a succinct answer. 1.22. What is the difference between the highest and the second highest Value added (% of GDP) of 1960?
Offer a very short reply. 0.39. What is the difference between the highest and the second highest Value added (% of GDP) of 1961?
Offer a terse response. 0.49. What is the difference between the highest and the second highest Value added (% of GDP) of 1962?
Provide a short and direct response. 2.06. What is the difference between the highest and the second highest Value added (% of GDP) in 1963?
Make the answer very short. 1.51. What is the difference between the highest and the lowest Value added (% of GDP) of 1960?
Ensure brevity in your answer.  17.05. What is the difference between the highest and the lowest Value added (% of GDP) of 1961?
Make the answer very short. 9.69. What is the difference between the highest and the lowest Value added (% of GDP) in 1962?
Your answer should be very brief. 8.72. What is the difference between the highest and the lowest Value added (% of GDP) in 1963?
Your answer should be compact. 8.97. 